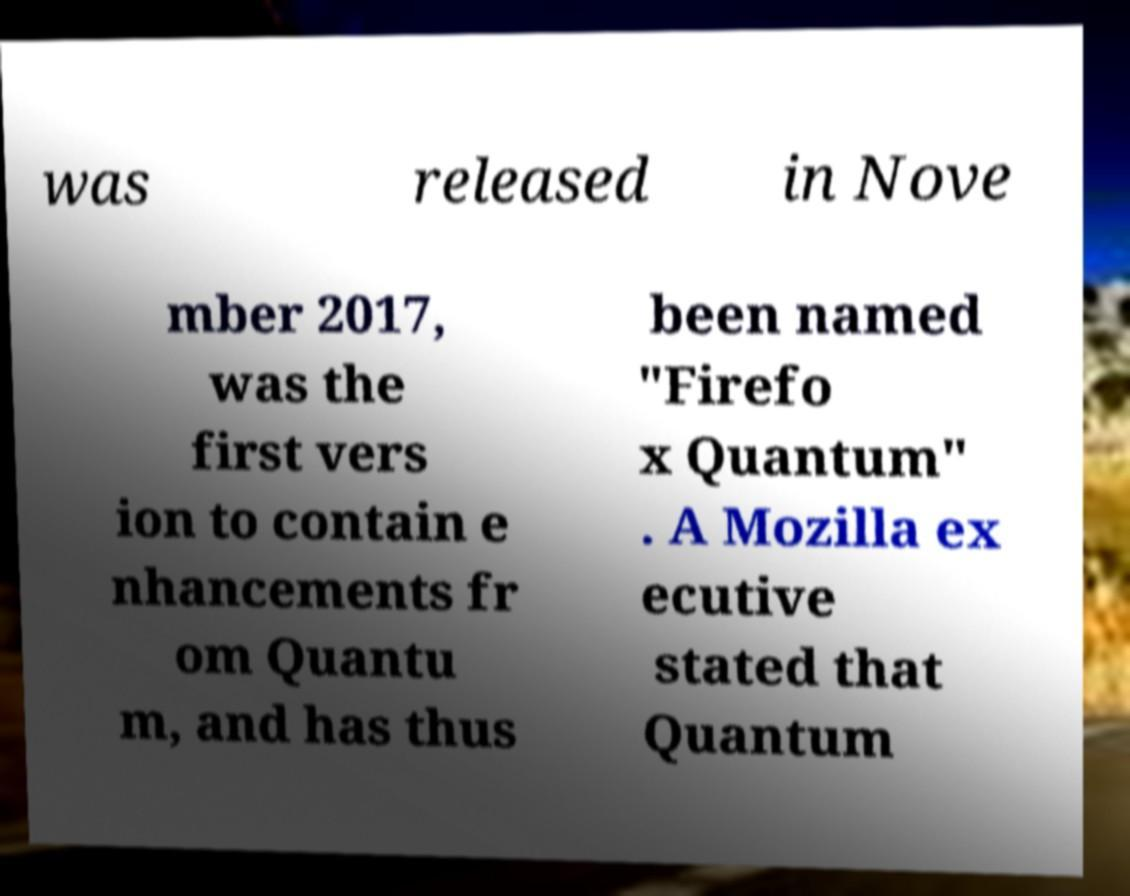Could you assist in decoding the text presented in this image and type it out clearly? was released in Nove mber 2017, was the first vers ion to contain e nhancements fr om Quantu m, and has thus been named "Firefo x Quantum" . A Mozilla ex ecutive stated that Quantum 